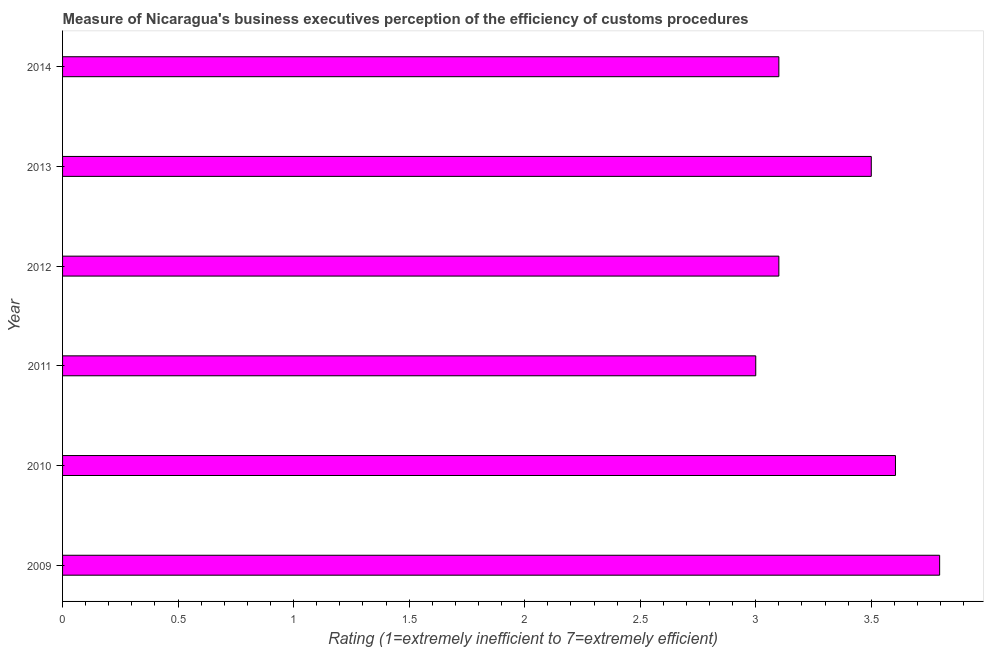Does the graph contain grids?
Give a very brief answer. No. What is the title of the graph?
Your answer should be very brief. Measure of Nicaragua's business executives perception of the efficiency of customs procedures. What is the label or title of the X-axis?
Offer a very short reply. Rating (1=extremely inefficient to 7=extremely efficient). Across all years, what is the maximum rating measuring burden of customs procedure?
Provide a short and direct response. 3.8. In which year was the rating measuring burden of customs procedure maximum?
Provide a succinct answer. 2009. In which year was the rating measuring burden of customs procedure minimum?
Your response must be concise. 2011. What is the sum of the rating measuring burden of customs procedure?
Offer a terse response. 20.1. What is the difference between the rating measuring burden of customs procedure in 2009 and 2012?
Offer a terse response. 0.7. What is the average rating measuring burden of customs procedure per year?
Make the answer very short. 3.35. In how many years, is the rating measuring burden of customs procedure greater than 3.2 ?
Ensure brevity in your answer.  3. Do a majority of the years between 2010 and 2013 (inclusive) have rating measuring burden of customs procedure greater than 2.8 ?
Your answer should be compact. Yes. What is the ratio of the rating measuring burden of customs procedure in 2012 to that in 2013?
Offer a very short reply. 0.89. Is the difference between the rating measuring burden of customs procedure in 2009 and 2013 greater than the difference between any two years?
Your answer should be very brief. No. What is the difference between the highest and the second highest rating measuring burden of customs procedure?
Your answer should be very brief. 0.19. Is the sum of the rating measuring burden of customs procedure in 2013 and 2014 greater than the maximum rating measuring burden of customs procedure across all years?
Ensure brevity in your answer.  Yes. Are all the bars in the graph horizontal?
Provide a short and direct response. Yes. What is the difference between two consecutive major ticks on the X-axis?
Make the answer very short. 0.5. What is the Rating (1=extremely inefficient to 7=extremely efficient) of 2009?
Your answer should be very brief. 3.8. What is the Rating (1=extremely inefficient to 7=extremely efficient) in 2010?
Make the answer very short. 3.6. What is the Rating (1=extremely inefficient to 7=extremely efficient) in 2011?
Offer a very short reply. 3. What is the Rating (1=extremely inefficient to 7=extremely efficient) of 2013?
Give a very brief answer. 3.5. What is the difference between the Rating (1=extremely inefficient to 7=extremely efficient) in 2009 and 2010?
Your answer should be compact. 0.19. What is the difference between the Rating (1=extremely inefficient to 7=extremely efficient) in 2009 and 2011?
Ensure brevity in your answer.  0.8. What is the difference between the Rating (1=extremely inefficient to 7=extremely efficient) in 2009 and 2012?
Offer a terse response. 0.7. What is the difference between the Rating (1=extremely inefficient to 7=extremely efficient) in 2009 and 2013?
Provide a short and direct response. 0.3. What is the difference between the Rating (1=extremely inefficient to 7=extremely efficient) in 2009 and 2014?
Provide a succinct answer. 0.7. What is the difference between the Rating (1=extremely inefficient to 7=extremely efficient) in 2010 and 2011?
Your answer should be very brief. 0.6. What is the difference between the Rating (1=extremely inefficient to 7=extremely efficient) in 2010 and 2012?
Your answer should be very brief. 0.5. What is the difference between the Rating (1=extremely inefficient to 7=extremely efficient) in 2010 and 2013?
Provide a short and direct response. 0.1. What is the difference between the Rating (1=extremely inefficient to 7=extremely efficient) in 2010 and 2014?
Offer a terse response. 0.5. What is the difference between the Rating (1=extremely inefficient to 7=extremely efficient) in 2011 and 2012?
Offer a very short reply. -0.1. What is the difference between the Rating (1=extremely inefficient to 7=extremely efficient) in 2011 and 2014?
Your answer should be very brief. -0.1. What is the difference between the Rating (1=extremely inefficient to 7=extremely efficient) in 2012 and 2013?
Provide a succinct answer. -0.4. What is the difference between the Rating (1=extremely inefficient to 7=extremely efficient) in 2012 and 2014?
Provide a short and direct response. 0. What is the ratio of the Rating (1=extremely inefficient to 7=extremely efficient) in 2009 to that in 2010?
Your answer should be very brief. 1.05. What is the ratio of the Rating (1=extremely inefficient to 7=extremely efficient) in 2009 to that in 2011?
Provide a succinct answer. 1.26. What is the ratio of the Rating (1=extremely inefficient to 7=extremely efficient) in 2009 to that in 2012?
Your answer should be compact. 1.22. What is the ratio of the Rating (1=extremely inefficient to 7=extremely efficient) in 2009 to that in 2013?
Your response must be concise. 1.08. What is the ratio of the Rating (1=extremely inefficient to 7=extremely efficient) in 2009 to that in 2014?
Offer a terse response. 1.22. What is the ratio of the Rating (1=extremely inefficient to 7=extremely efficient) in 2010 to that in 2011?
Ensure brevity in your answer.  1.2. What is the ratio of the Rating (1=extremely inefficient to 7=extremely efficient) in 2010 to that in 2012?
Keep it short and to the point. 1.16. What is the ratio of the Rating (1=extremely inefficient to 7=extremely efficient) in 2010 to that in 2014?
Provide a short and direct response. 1.16. What is the ratio of the Rating (1=extremely inefficient to 7=extremely efficient) in 2011 to that in 2012?
Your response must be concise. 0.97. What is the ratio of the Rating (1=extremely inefficient to 7=extremely efficient) in 2011 to that in 2013?
Your answer should be compact. 0.86. What is the ratio of the Rating (1=extremely inefficient to 7=extremely efficient) in 2011 to that in 2014?
Your answer should be compact. 0.97. What is the ratio of the Rating (1=extremely inefficient to 7=extremely efficient) in 2012 to that in 2013?
Offer a very short reply. 0.89. What is the ratio of the Rating (1=extremely inefficient to 7=extremely efficient) in 2012 to that in 2014?
Offer a terse response. 1. What is the ratio of the Rating (1=extremely inefficient to 7=extremely efficient) in 2013 to that in 2014?
Ensure brevity in your answer.  1.13. 